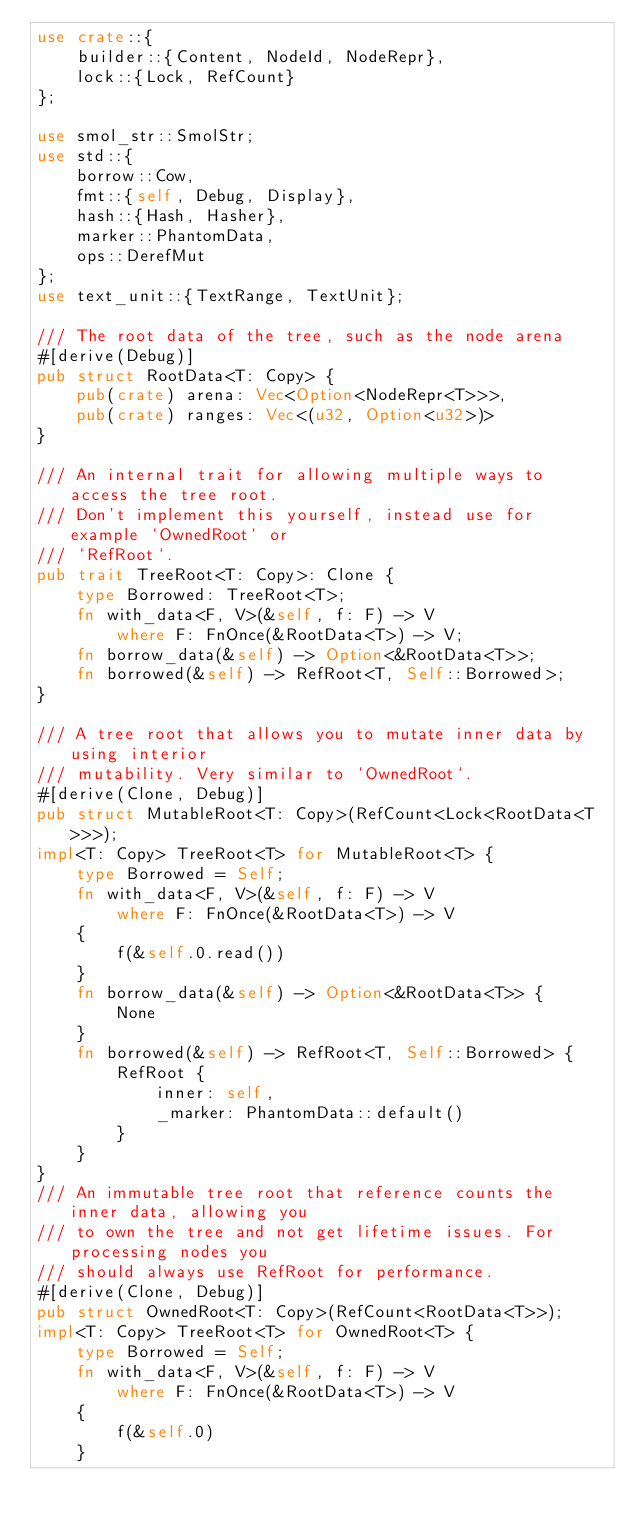Convert code to text. <code><loc_0><loc_0><loc_500><loc_500><_Rust_>use crate::{
    builder::{Content, NodeId, NodeRepr},
    lock::{Lock, RefCount}
};

use smol_str::SmolStr;
use std::{
    borrow::Cow,
    fmt::{self, Debug, Display},
    hash::{Hash, Hasher},
    marker::PhantomData,
    ops::DerefMut
};
use text_unit::{TextRange, TextUnit};

/// The root data of the tree, such as the node arena
#[derive(Debug)]
pub struct RootData<T: Copy> {
    pub(crate) arena: Vec<Option<NodeRepr<T>>>,
    pub(crate) ranges: Vec<(u32, Option<u32>)>
}

/// An internal trait for allowing multiple ways to access the tree root.
/// Don't implement this yourself, instead use for example `OwnedRoot` or
/// `RefRoot`.
pub trait TreeRoot<T: Copy>: Clone {
    type Borrowed: TreeRoot<T>;
    fn with_data<F, V>(&self, f: F) -> V
        where F: FnOnce(&RootData<T>) -> V;
    fn borrow_data(&self) -> Option<&RootData<T>>;
    fn borrowed(&self) -> RefRoot<T, Self::Borrowed>;
}

/// A tree root that allows you to mutate inner data by using interior
/// mutability. Very similar to `OwnedRoot`.
#[derive(Clone, Debug)]
pub struct MutableRoot<T: Copy>(RefCount<Lock<RootData<T>>>);
impl<T: Copy> TreeRoot<T> for MutableRoot<T> {
    type Borrowed = Self;
    fn with_data<F, V>(&self, f: F) -> V
        where F: FnOnce(&RootData<T>) -> V
    {
        f(&self.0.read())
    }
    fn borrow_data(&self) -> Option<&RootData<T>> {
        None
    }
    fn borrowed(&self) -> RefRoot<T, Self::Borrowed> {
        RefRoot {
            inner: self,
            _marker: PhantomData::default()
        }
    }
}
/// An immutable tree root that reference counts the inner data, allowing you
/// to own the tree and not get lifetime issues. For processing nodes you
/// should always use RefRoot for performance.
#[derive(Clone, Debug)]
pub struct OwnedRoot<T: Copy>(RefCount<RootData<T>>);
impl<T: Copy> TreeRoot<T> for OwnedRoot<T> {
    type Borrowed = Self;
    fn with_data<F, V>(&self, f: F) -> V
        where F: FnOnce(&RootData<T>) -> V
    {
        f(&self.0)
    }</code> 